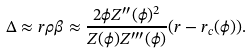Convert formula to latex. <formula><loc_0><loc_0><loc_500><loc_500>\Delta \approx r \rho \beta \approx \frac { 2 \phi Z ^ { \prime \prime } ( \phi ) ^ { 2 } } { Z ( \phi ) Z ^ { \prime \prime \prime } ( \phi ) } ( r - r _ { c } ( \phi ) ) .</formula> 